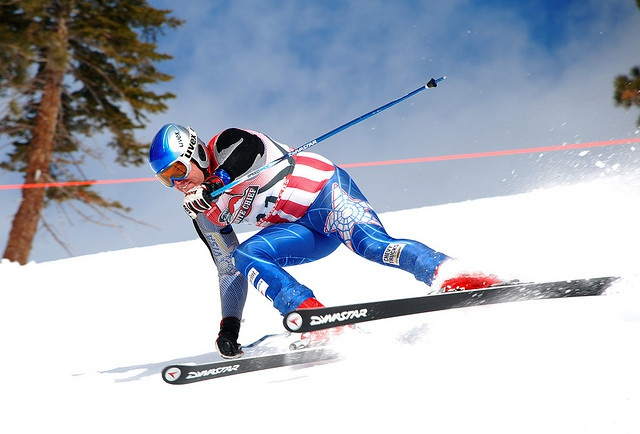Describe the objects in this image and their specific colors. I can see people in black, white, blue, and darkgray tones and skis in black, gray, white, and darkgray tones in this image. 